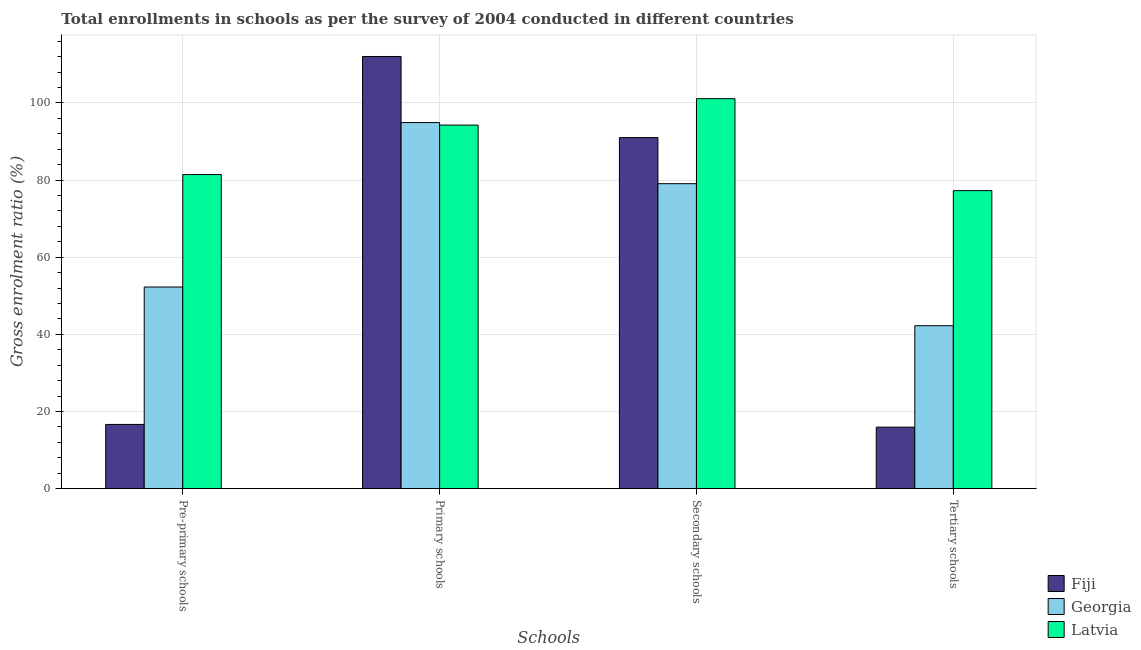How many groups of bars are there?
Keep it short and to the point. 4. How many bars are there on the 3rd tick from the left?
Your answer should be compact. 3. How many bars are there on the 1st tick from the right?
Keep it short and to the point. 3. What is the label of the 3rd group of bars from the left?
Provide a short and direct response. Secondary schools. What is the gross enrolment ratio in secondary schools in Fiji?
Offer a terse response. 91.01. Across all countries, what is the maximum gross enrolment ratio in primary schools?
Make the answer very short. 112.03. Across all countries, what is the minimum gross enrolment ratio in tertiary schools?
Offer a terse response. 15.95. In which country was the gross enrolment ratio in secondary schools maximum?
Give a very brief answer. Latvia. In which country was the gross enrolment ratio in primary schools minimum?
Keep it short and to the point. Latvia. What is the total gross enrolment ratio in primary schools in the graph?
Your answer should be very brief. 301.19. What is the difference between the gross enrolment ratio in primary schools in Latvia and that in Fiji?
Make the answer very short. -17.78. What is the difference between the gross enrolment ratio in pre-primary schools in Fiji and the gross enrolment ratio in tertiary schools in Georgia?
Give a very brief answer. -25.58. What is the average gross enrolment ratio in tertiary schools per country?
Ensure brevity in your answer.  45.15. What is the difference between the gross enrolment ratio in secondary schools and gross enrolment ratio in primary schools in Georgia?
Your answer should be very brief. -15.84. What is the ratio of the gross enrolment ratio in secondary schools in Fiji to that in Latvia?
Provide a succinct answer. 0.9. Is the difference between the gross enrolment ratio in primary schools in Latvia and Fiji greater than the difference between the gross enrolment ratio in tertiary schools in Latvia and Fiji?
Make the answer very short. No. What is the difference between the highest and the second highest gross enrolment ratio in pre-primary schools?
Your response must be concise. 29.15. What is the difference between the highest and the lowest gross enrolment ratio in secondary schools?
Offer a very short reply. 22.03. In how many countries, is the gross enrolment ratio in secondary schools greater than the average gross enrolment ratio in secondary schools taken over all countries?
Give a very brief answer. 2. Is the sum of the gross enrolment ratio in primary schools in Georgia and Latvia greater than the maximum gross enrolment ratio in pre-primary schools across all countries?
Provide a succinct answer. Yes. What does the 1st bar from the left in Primary schools represents?
Give a very brief answer. Fiji. What does the 1st bar from the right in Tertiary schools represents?
Provide a short and direct response. Latvia. Is it the case that in every country, the sum of the gross enrolment ratio in pre-primary schools and gross enrolment ratio in primary schools is greater than the gross enrolment ratio in secondary schools?
Offer a very short reply. Yes. How many bars are there?
Provide a short and direct response. 12. Are all the bars in the graph horizontal?
Your answer should be compact. No. Does the graph contain any zero values?
Make the answer very short. No. How many legend labels are there?
Provide a short and direct response. 3. How are the legend labels stacked?
Give a very brief answer. Vertical. What is the title of the graph?
Make the answer very short. Total enrollments in schools as per the survey of 2004 conducted in different countries. Does "High income: OECD" appear as one of the legend labels in the graph?
Ensure brevity in your answer.  No. What is the label or title of the X-axis?
Ensure brevity in your answer.  Schools. What is the label or title of the Y-axis?
Your answer should be very brief. Gross enrolment ratio (%). What is the Gross enrolment ratio (%) of Fiji in Pre-primary schools?
Give a very brief answer. 16.65. What is the Gross enrolment ratio (%) in Georgia in Pre-primary schools?
Keep it short and to the point. 52.27. What is the Gross enrolment ratio (%) in Latvia in Pre-primary schools?
Make the answer very short. 81.43. What is the Gross enrolment ratio (%) in Fiji in Primary schools?
Offer a terse response. 112.03. What is the Gross enrolment ratio (%) of Georgia in Primary schools?
Your answer should be very brief. 94.9. What is the Gross enrolment ratio (%) in Latvia in Primary schools?
Your answer should be compact. 94.25. What is the Gross enrolment ratio (%) of Fiji in Secondary schools?
Keep it short and to the point. 91.01. What is the Gross enrolment ratio (%) in Georgia in Secondary schools?
Provide a short and direct response. 79.06. What is the Gross enrolment ratio (%) in Latvia in Secondary schools?
Ensure brevity in your answer.  101.1. What is the Gross enrolment ratio (%) of Fiji in Tertiary schools?
Your response must be concise. 15.95. What is the Gross enrolment ratio (%) of Georgia in Tertiary schools?
Ensure brevity in your answer.  42.24. What is the Gross enrolment ratio (%) of Latvia in Tertiary schools?
Make the answer very short. 77.26. Across all Schools, what is the maximum Gross enrolment ratio (%) of Fiji?
Ensure brevity in your answer.  112.03. Across all Schools, what is the maximum Gross enrolment ratio (%) in Georgia?
Your answer should be compact. 94.9. Across all Schools, what is the maximum Gross enrolment ratio (%) of Latvia?
Offer a very short reply. 101.1. Across all Schools, what is the minimum Gross enrolment ratio (%) of Fiji?
Offer a very short reply. 15.95. Across all Schools, what is the minimum Gross enrolment ratio (%) of Georgia?
Offer a terse response. 42.24. Across all Schools, what is the minimum Gross enrolment ratio (%) in Latvia?
Provide a short and direct response. 77.26. What is the total Gross enrolment ratio (%) in Fiji in the graph?
Give a very brief answer. 235.65. What is the total Gross enrolment ratio (%) in Georgia in the graph?
Your response must be concise. 268.48. What is the total Gross enrolment ratio (%) of Latvia in the graph?
Keep it short and to the point. 354.03. What is the difference between the Gross enrolment ratio (%) in Fiji in Pre-primary schools and that in Primary schools?
Ensure brevity in your answer.  -95.38. What is the difference between the Gross enrolment ratio (%) of Georgia in Pre-primary schools and that in Primary schools?
Give a very brief answer. -42.63. What is the difference between the Gross enrolment ratio (%) of Latvia in Pre-primary schools and that in Primary schools?
Offer a terse response. -12.82. What is the difference between the Gross enrolment ratio (%) in Fiji in Pre-primary schools and that in Secondary schools?
Ensure brevity in your answer.  -74.35. What is the difference between the Gross enrolment ratio (%) in Georgia in Pre-primary schools and that in Secondary schools?
Make the answer very short. -26.79. What is the difference between the Gross enrolment ratio (%) in Latvia in Pre-primary schools and that in Secondary schools?
Your response must be concise. -19.67. What is the difference between the Gross enrolment ratio (%) in Fiji in Pre-primary schools and that in Tertiary schools?
Your answer should be very brief. 0.7. What is the difference between the Gross enrolment ratio (%) in Georgia in Pre-primary schools and that in Tertiary schools?
Provide a short and direct response. 10.04. What is the difference between the Gross enrolment ratio (%) of Latvia in Pre-primary schools and that in Tertiary schools?
Your response must be concise. 4.17. What is the difference between the Gross enrolment ratio (%) in Fiji in Primary schools and that in Secondary schools?
Offer a terse response. 21.03. What is the difference between the Gross enrolment ratio (%) in Georgia in Primary schools and that in Secondary schools?
Provide a succinct answer. 15.84. What is the difference between the Gross enrolment ratio (%) in Latvia in Primary schools and that in Secondary schools?
Your answer should be very brief. -6.84. What is the difference between the Gross enrolment ratio (%) of Fiji in Primary schools and that in Tertiary schools?
Make the answer very short. 96.08. What is the difference between the Gross enrolment ratio (%) in Georgia in Primary schools and that in Tertiary schools?
Your answer should be compact. 52.67. What is the difference between the Gross enrolment ratio (%) in Latvia in Primary schools and that in Tertiary schools?
Give a very brief answer. 16.99. What is the difference between the Gross enrolment ratio (%) in Fiji in Secondary schools and that in Tertiary schools?
Your answer should be very brief. 75.05. What is the difference between the Gross enrolment ratio (%) of Georgia in Secondary schools and that in Tertiary schools?
Your answer should be compact. 36.82. What is the difference between the Gross enrolment ratio (%) in Latvia in Secondary schools and that in Tertiary schools?
Give a very brief answer. 23.84. What is the difference between the Gross enrolment ratio (%) in Fiji in Pre-primary schools and the Gross enrolment ratio (%) in Georgia in Primary schools?
Offer a terse response. -78.25. What is the difference between the Gross enrolment ratio (%) of Fiji in Pre-primary schools and the Gross enrolment ratio (%) of Latvia in Primary schools?
Provide a succinct answer. -77.6. What is the difference between the Gross enrolment ratio (%) in Georgia in Pre-primary schools and the Gross enrolment ratio (%) in Latvia in Primary schools?
Offer a terse response. -41.98. What is the difference between the Gross enrolment ratio (%) in Fiji in Pre-primary schools and the Gross enrolment ratio (%) in Georgia in Secondary schools?
Make the answer very short. -62.41. What is the difference between the Gross enrolment ratio (%) of Fiji in Pre-primary schools and the Gross enrolment ratio (%) of Latvia in Secondary schools?
Offer a terse response. -84.44. What is the difference between the Gross enrolment ratio (%) of Georgia in Pre-primary schools and the Gross enrolment ratio (%) of Latvia in Secondary schools?
Your answer should be compact. -48.82. What is the difference between the Gross enrolment ratio (%) of Fiji in Pre-primary schools and the Gross enrolment ratio (%) of Georgia in Tertiary schools?
Provide a succinct answer. -25.58. What is the difference between the Gross enrolment ratio (%) in Fiji in Pre-primary schools and the Gross enrolment ratio (%) in Latvia in Tertiary schools?
Your answer should be compact. -60.61. What is the difference between the Gross enrolment ratio (%) of Georgia in Pre-primary schools and the Gross enrolment ratio (%) of Latvia in Tertiary schools?
Provide a succinct answer. -24.99. What is the difference between the Gross enrolment ratio (%) in Fiji in Primary schools and the Gross enrolment ratio (%) in Georgia in Secondary schools?
Keep it short and to the point. 32.97. What is the difference between the Gross enrolment ratio (%) in Fiji in Primary schools and the Gross enrolment ratio (%) in Latvia in Secondary schools?
Make the answer very short. 10.94. What is the difference between the Gross enrolment ratio (%) in Georgia in Primary schools and the Gross enrolment ratio (%) in Latvia in Secondary schools?
Offer a very short reply. -6.19. What is the difference between the Gross enrolment ratio (%) in Fiji in Primary schools and the Gross enrolment ratio (%) in Georgia in Tertiary schools?
Provide a short and direct response. 69.8. What is the difference between the Gross enrolment ratio (%) in Fiji in Primary schools and the Gross enrolment ratio (%) in Latvia in Tertiary schools?
Offer a terse response. 34.77. What is the difference between the Gross enrolment ratio (%) in Georgia in Primary schools and the Gross enrolment ratio (%) in Latvia in Tertiary schools?
Make the answer very short. 17.64. What is the difference between the Gross enrolment ratio (%) of Fiji in Secondary schools and the Gross enrolment ratio (%) of Georgia in Tertiary schools?
Keep it short and to the point. 48.77. What is the difference between the Gross enrolment ratio (%) in Fiji in Secondary schools and the Gross enrolment ratio (%) in Latvia in Tertiary schools?
Offer a very short reply. 13.75. What is the difference between the Gross enrolment ratio (%) of Georgia in Secondary schools and the Gross enrolment ratio (%) of Latvia in Tertiary schools?
Give a very brief answer. 1.8. What is the average Gross enrolment ratio (%) of Fiji per Schools?
Your answer should be very brief. 58.91. What is the average Gross enrolment ratio (%) of Georgia per Schools?
Ensure brevity in your answer.  67.12. What is the average Gross enrolment ratio (%) of Latvia per Schools?
Ensure brevity in your answer.  88.51. What is the difference between the Gross enrolment ratio (%) of Fiji and Gross enrolment ratio (%) of Georgia in Pre-primary schools?
Provide a short and direct response. -35.62. What is the difference between the Gross enrolment ratio (%) of Fiji and Gross enrolment ratio (%) of Latvia in Pre-primary schools?
Offer a very short reply. -64.77. What is the difference between the Gross enrolment ratio (%) of Georgia and Gross enrolment ratio (%) of Latvia in Pre-primary schools?
Your answer should be very brief. -29.15. What is the difference between the Gross enrolment ratio (%) in Fiji and Gross enrolment ratio (%) in Georgia in Primary schools?
Offer a very short reply. 17.13. What is the difference between the Gross enrolment ratio (%) in Fiji and Gross enrolment ratio (%) in Latvia in Primary schools?
Your answer should be compact. 17.78. What is the difference between the Gross enrolment ratio (%) of Georgia and Gross enrolment ratio (%) of Latvia in Primary schools?
Your answer should be compact. 0.65. What is the difference between the Gross enrolment ratio (%) in Fiji and Gross enrolment ratio (%) in Georgia in Secondary schools?
Give a very brief answer. 11.94. What is the difference between the Gross enrolment ratio (%) in Fiji and Gross enrolment ratio (%) in Latvia in Secondary schools?
Your answer should be very brief. -10.09. What is the difference between the Gross enrolment ratio (%) in Georgia and Gross enrolment ratio (%) in Latvia in Secondary schools?
Provide a short and direct response. -22.03. What is the difference between the Gross enrolment ratio (%) in Fiji and Gross enrolment ratio (%) in Georgia in Tertiary schools?
Give a very brief answer. -26.29. What is the difference between the Gross enrolment ratio (%) of Fiji and Gross enrolment ratio (%) of Latvia in Tertiary schools?
Offer a terse response. -61.31. What is the difference between the Gross enrolment ratio (%) of Georgia and Gross enrolment ratio (%) of Latvia in Tertiary schools?
Keep it short and to the point. -35.02. What is the ratio of the Gross enrolment ratio (%) in Fiji in Pre-primary schools to that in Primary schools?
Your answer should be very brief. 0.15. What is the ratio of the Gross enrolment ratio (%) in Georgia in Pre-primary schools to that in Primary schools?
Provide a short and direct response. 0.55. What is the ratio of the Gross enrolment ratio (%) in Latvia in Pre-primary schools to that in Primary schools?
Your answer should be compact. 0.86. What is the ratio of the Gross enrolment ratio (%) in Fiji in Pre-primary schools to that in Secondary schools?
Ensure brevity in your answer.  0.18. What is the ratio of the Gross enrolment ratio (%) of Georgia in Pre-primary schools to that in Secondary schools?
Make the answer very short. 0.66. What is the ratio of the Gross enrolment ratio (%) of Latvia in Pre-primary schools to that in Secondary schools?
Offer a terse response. 0.81. What is the ratio of the Gross enrolment ratio (%) of Fiji in Pre-primary schools to that in Tertiary schools?
Give a very brief answer. 1.04. What is the ratio of the Gross enrolment ratio (%) in Georgia in Pre-primary schools to that in Tertiary schools?
Make the answer very short. 1.24. What is the ratio of the Gross enrolment ratio (%) in Latvia in Pre-primary schools to that in Tertiary schools?
Your response must be concise. 1.05. What is the ratio of the Gross enrolment ratio (%) in Fiji in Primary schools to that in Secondary schools?
Keep it short and to the point. 1.23. What is the ratio of the Gross enrolment ratio (%) of Georgia in Primary schools to that in Secondary schools?
Give a very brief answer. 1.2. What is the ratio of the Gross enrolment ratio (%) of Latvia in Primary schools to that in Secondary schools?
Offer a terse response. 0.93. What is the ratio of the Gross enrolment ratio (%) of Fiji in Primary schools to that in Tertiary schools?
Your answer should be very brief. 7.02. What is the ratio of the Gross enrolment ratio (%) in Georgia in Primary schools to that in Tertiary schools?
Ensure brevity in your answer.  2.25. What is the ratio of the Gross enrolment ratio (%) of Latvia in Primary schools to that in Tertiary schools?
Provide a succinct answer. 1.22. What is the ratio of the Gross enrolment ratio (%) of Fiji in Secondary schools to that in Tertiary schools?
Offer a terse response. 5.71. What is the ratio of the Gross enrolment ratio (%) in Georgia in Secondary schools to that in Tertiary schools?
Your answer should be compact. 1.87. What is the ratio of the Gross enrolment ratio (%) in Latvia in Secondary schools to that in Tertiary schools?
Ensure brevity in your answer.  1.31. What is the difference between the highest and the second highest Gross enrolment ratio (%) in Fiji?
Make the answer very short. 21.03. What is the difference between the highest and the second highest Gross enrolment ratio (%) of Georgia?
Provide a succinct answer. 15.84. What is the difference between the highest and the second highest Gross enrolment ratio (%) of Latvia?
Your response must be concise. 6.84. What is the difference between the highest and the lowest Gross enrolment ratio (%) in Fiji?
Your answer should be very brief. 96.08. What is the difference between the highest and the lowest Gross enrolment ratio (%) in Georgia?
Offer a very short reply. 52.67. What is the difference between the highest and the lowest Gross enrolment ratio (%) of Latvia?
Provide a succinct answer. 23.84. 